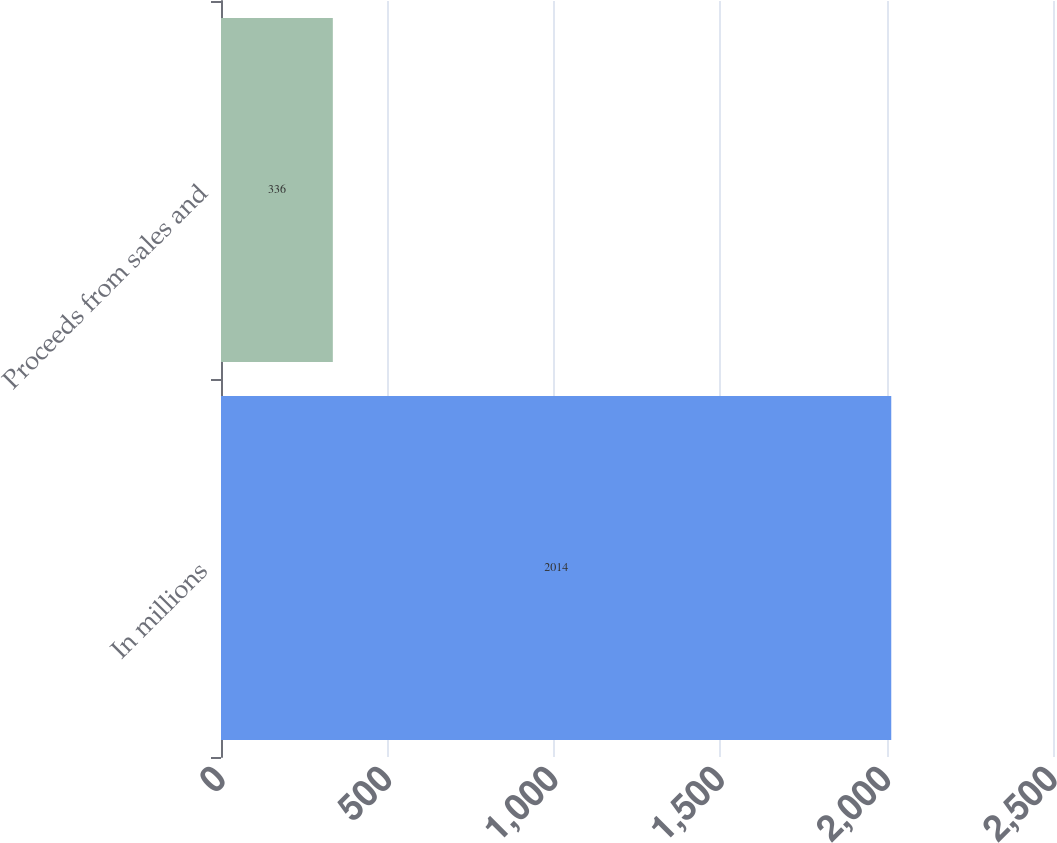<chart> <loc_0><loc_0><loc_500><loc_500><bar_chart><fcel>In millions<fcel>Proceeds from sales and<nl><fcel>2014<fcel>336<nl></chart> 